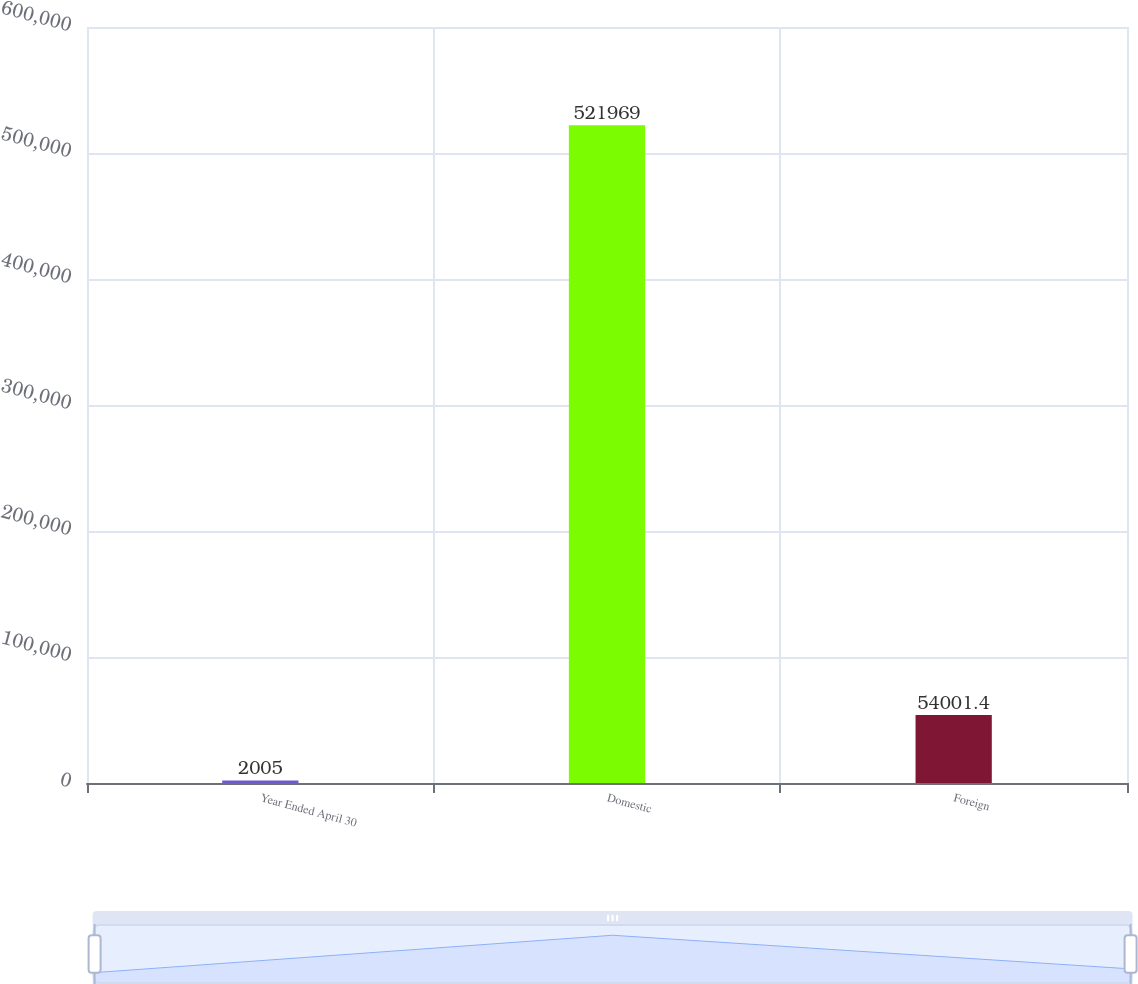<chart> <loc_0><loc_0><loc_500><loc_500><bar_chart><fcel>Year Ended April 30<fcel>Domestic<fcel>Foreign<nl><fcel>2005<fcel>521969<fcel>54001.4<nl></chart> 